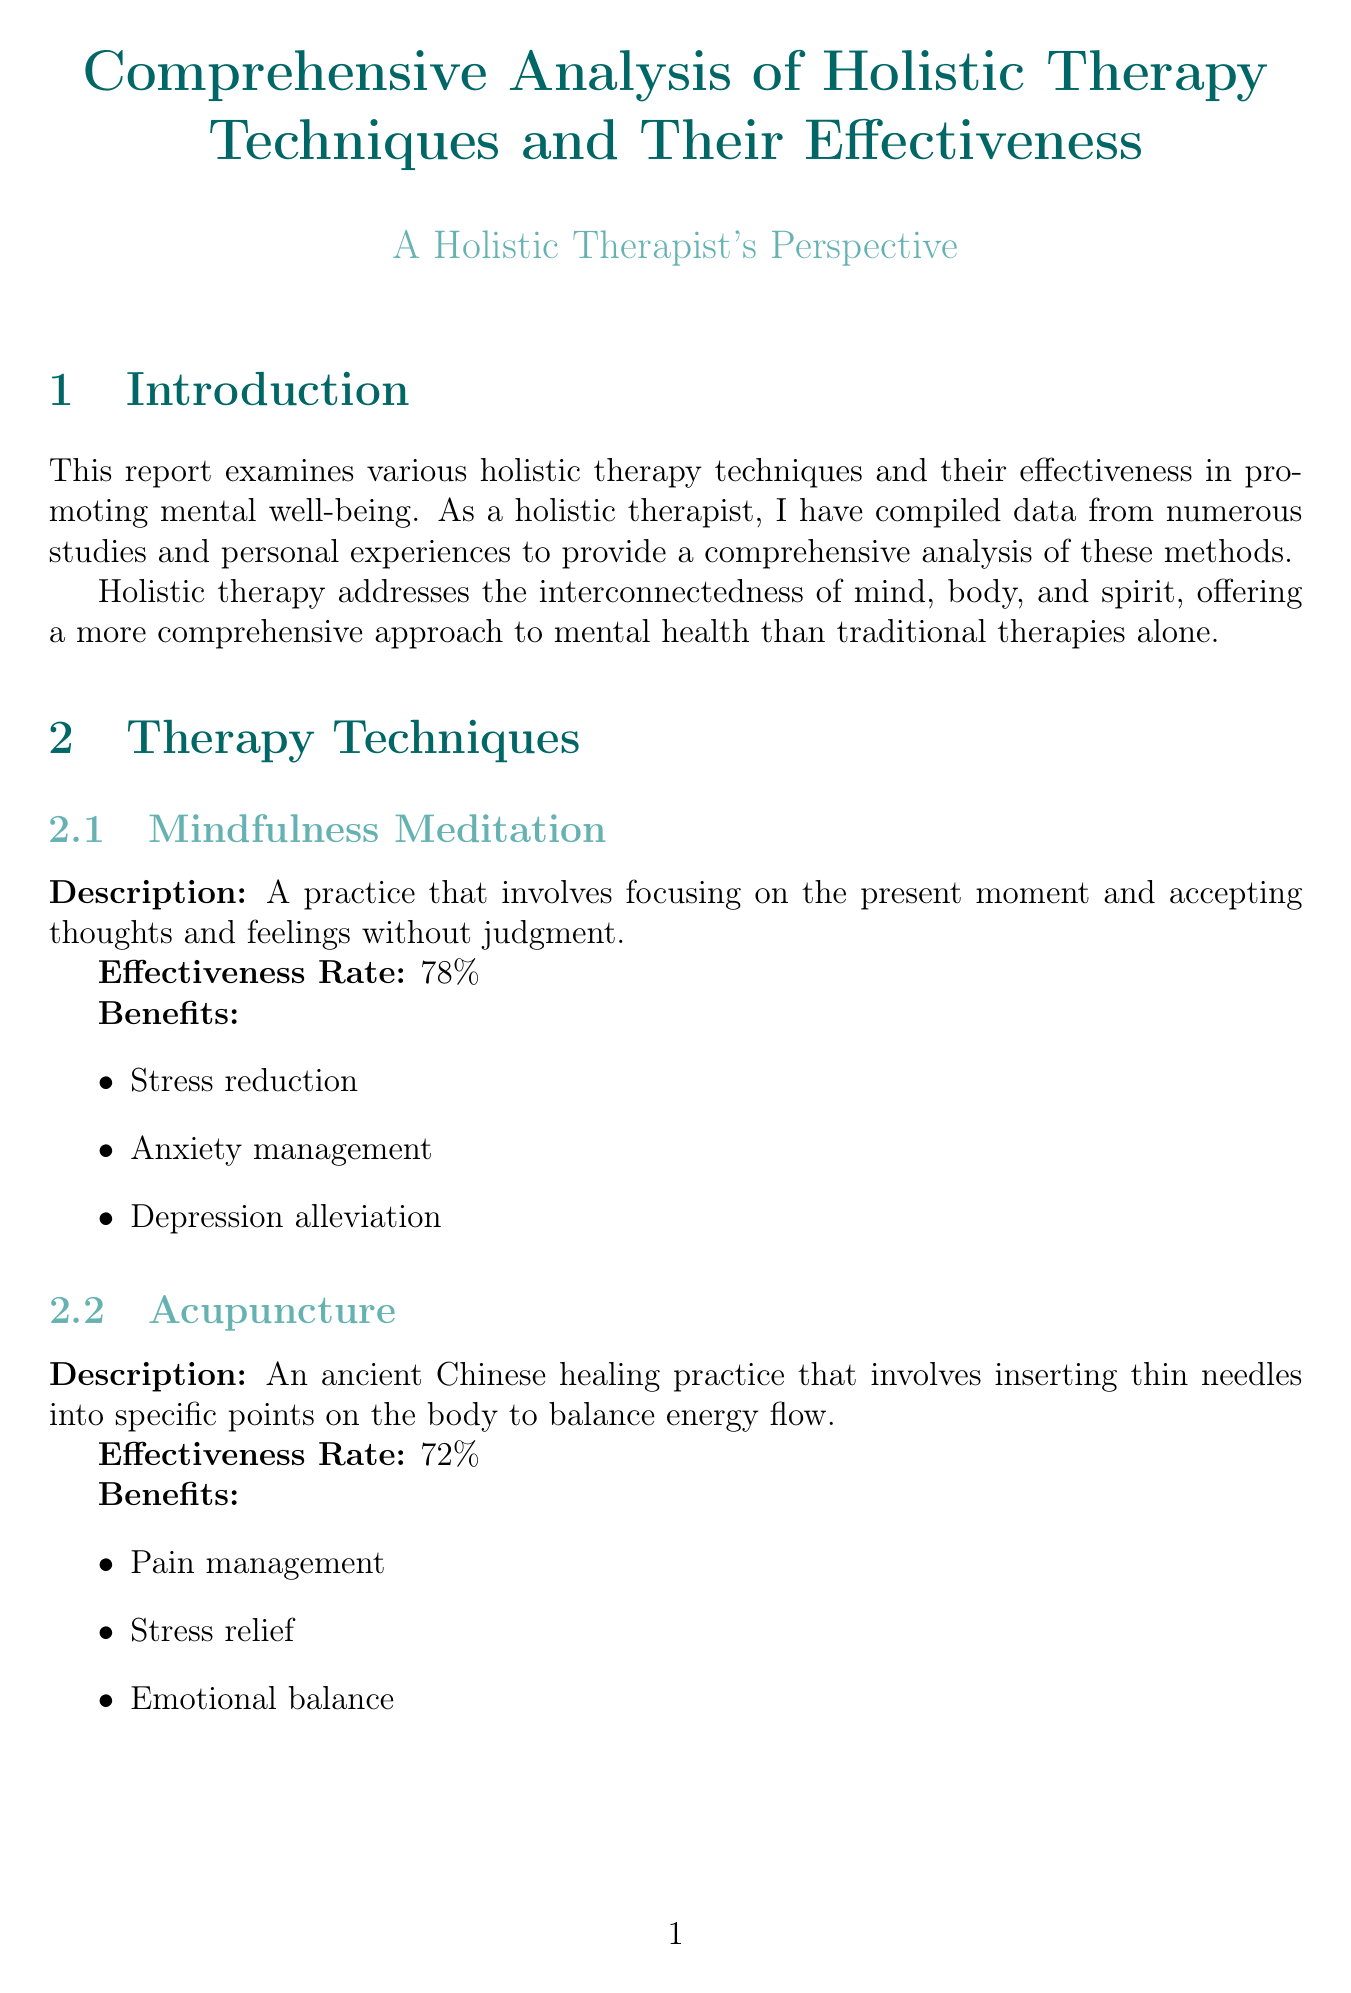What is the effectiveness rate of Yoga? The effectiveness rate of Yoga is specified in the report as 85%.
Answer: 85% What are the benefits of Art Therapy? The benefits of Art Therapy include emotional expression, trauma processing, and self-discovery.
Answer: Emotional expression, trauma processing, self-discovery Who is the client in the case study for managing chronic pain through Acupuncture? The client in the Acupuncture case study is named Michael Chen, a 52-year-old construction worker.
Answer: Michael Chen What is the conclusion of the comparative analysis between holistic therapy and traditional psychotherapy? The conclusion states that while both approaches have merits, holistic therapy offers a more comprehensive treatment plan that can complement traditional psychotherapy.
Answer: More comprehensive treatment plan Which holistic therapy technique has the highest effectiveness rate? The report lists the effectiveness rates, identifying Yoga as the technique with the highest at 85%.
Answer: Yoga What is the percentage distribution of Mindfulness Meditation usage? The report indicates that Mindfulness Meditation comprises 30% of holistic therapy usage distribution.
Answer: 30% What future trend involves technology integration? The document mentions the integration of technology in holistic practices, such as VR-guided meditation.
Answer: VR-guided meditation What is the general recommendation for achieving mental well-being? The recommendation emphasizes a personalized combination of various techniques based on individual needs and preferences.
Answer: Personalized combination of techniques 